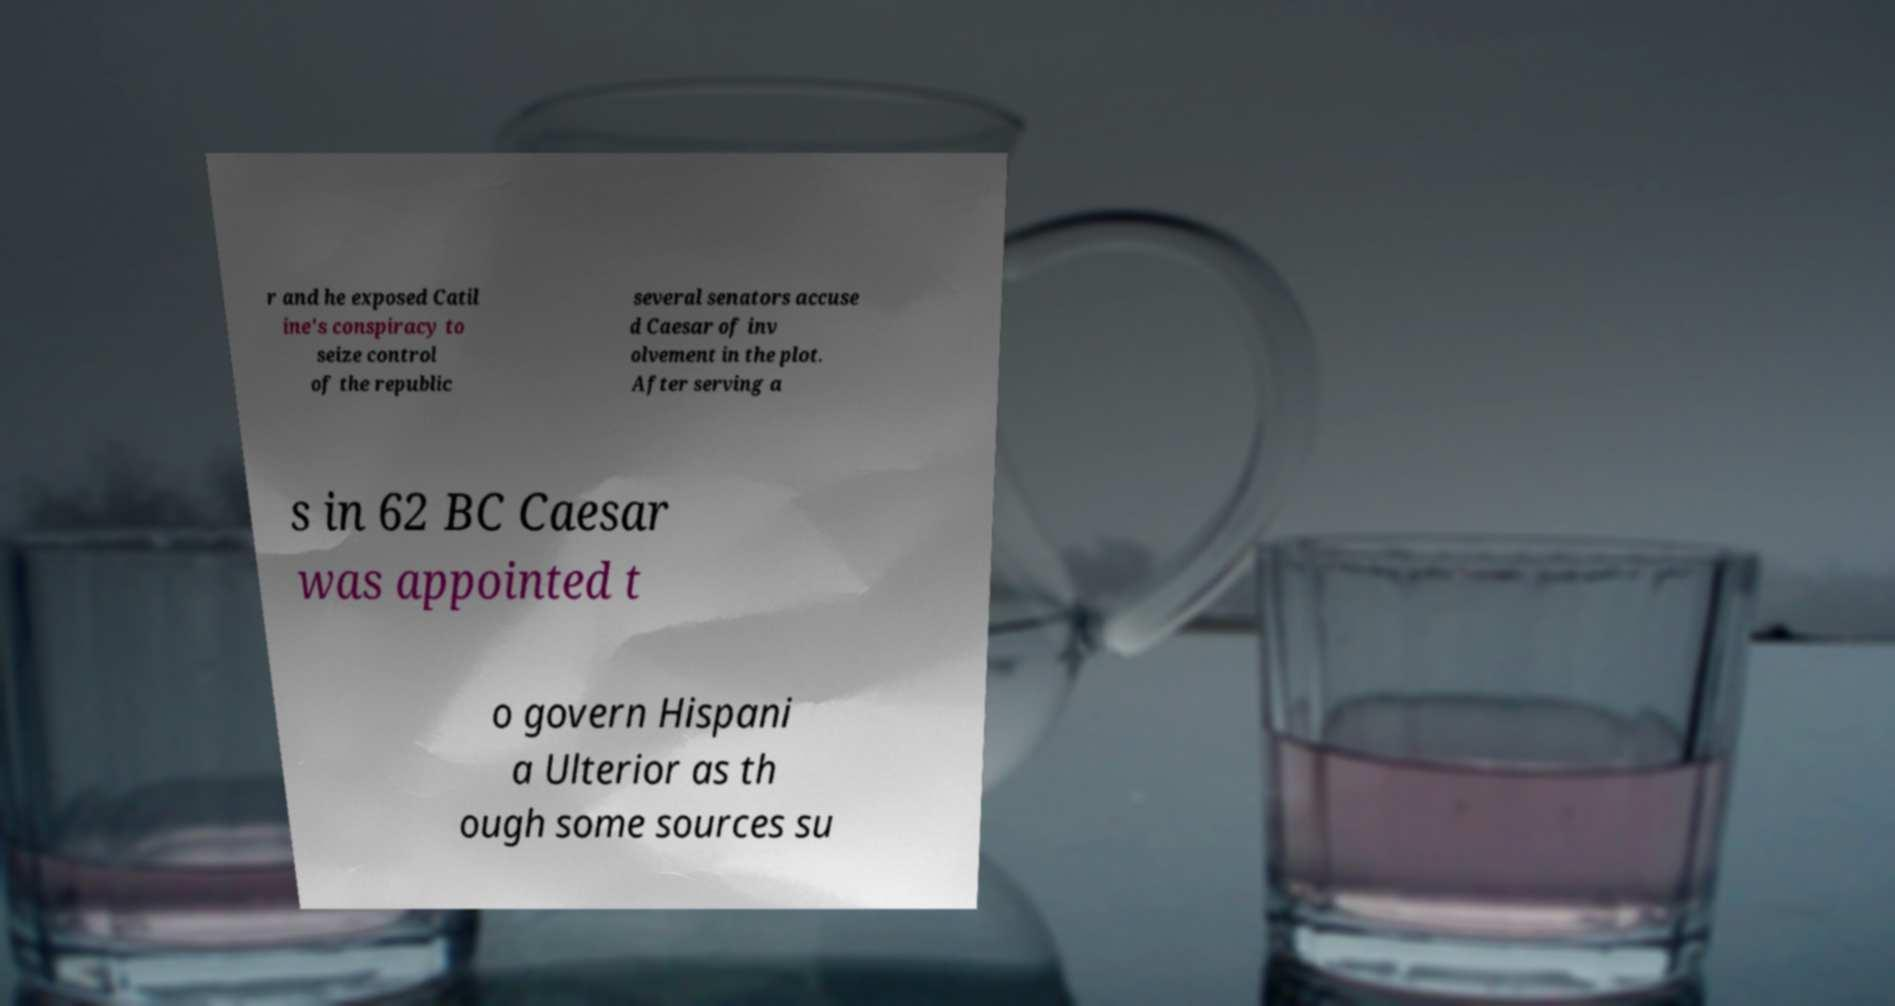There's text embedded in this image that I need extracted. Can you transcribe it verbatim? r and he exposed Catil ine's conspiracy to seize control of the republic several senators accuse d Caesar of inv olvement in the plot. After serving a s in 62 BC Caesar was appointed t o govern Hispani a Ulterior as th ough some sources su 